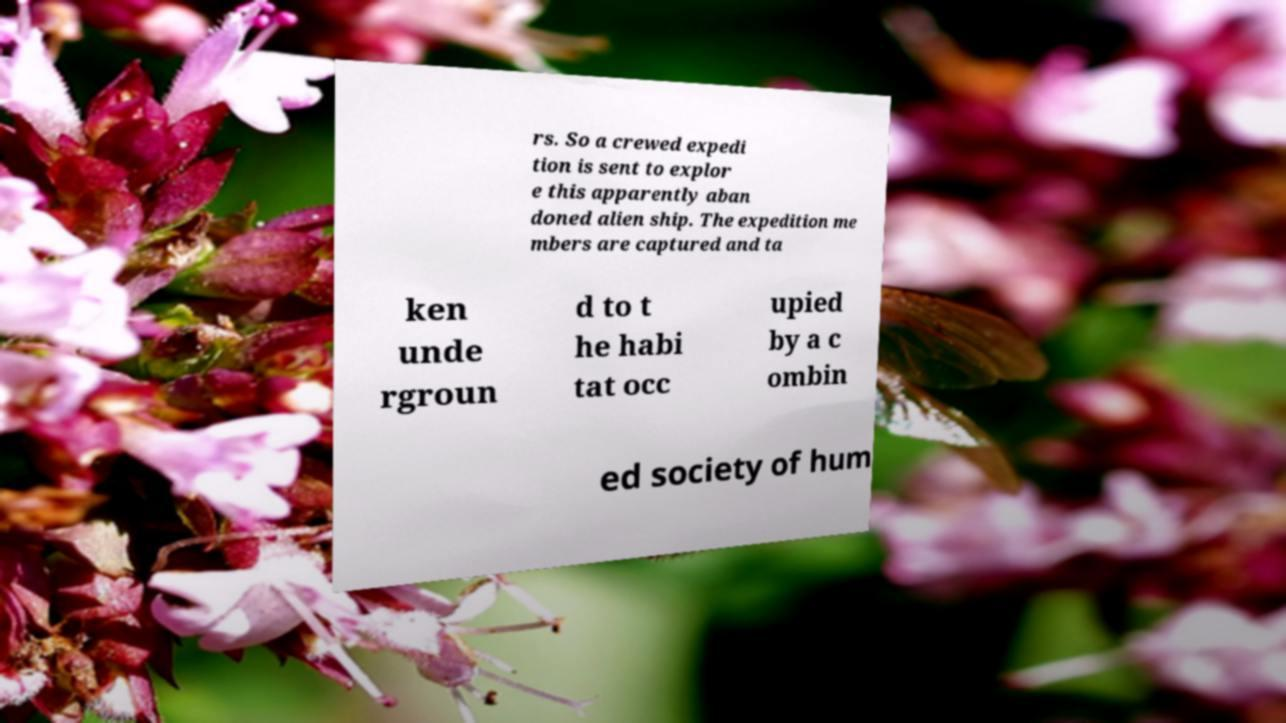There's text embedded in this image that I need extracted. Can you transcribe it verbatim? rs. So a crewed expedi tion is sent to explor e this apparently aban doned alien ship. The expedition me mbers are captured and ta ken unde rgroun d to t he habi tat occ upied by a c ombin ed society of hum 